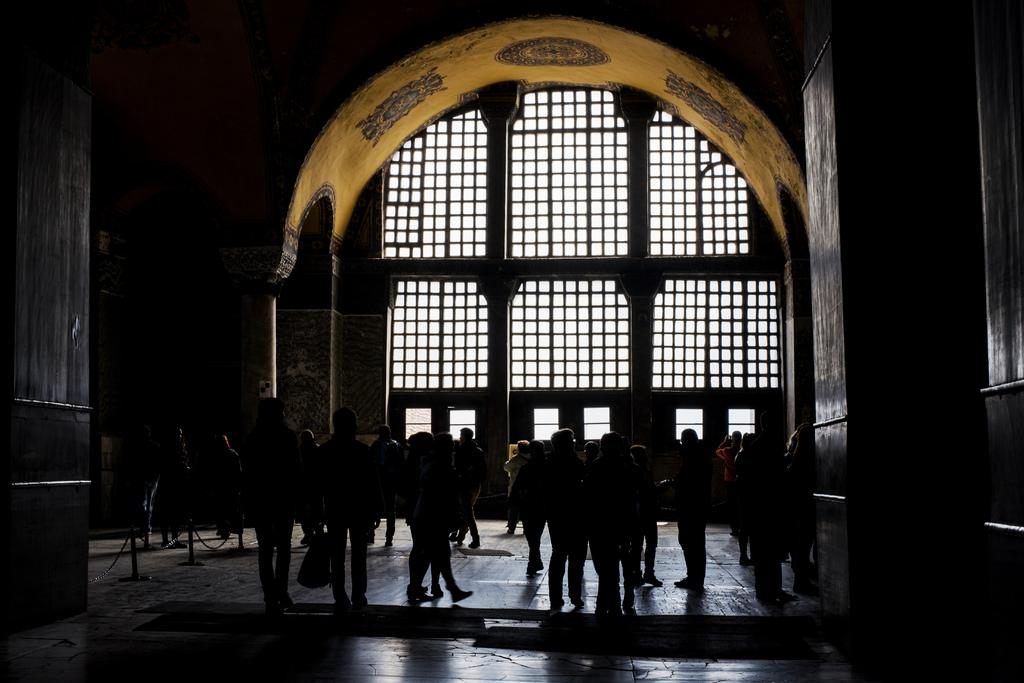How many people are in the group that is visible in the image? There is a group of people standing in the image, but the exact number is not specified. What can be seen in the background of the image? There is an arch in the background of the image. What type of structure is visible in the image? There is railing visible in the image. What is the color of the sky in the image? The sky appears to be white in color. What time is displayed on the clock in the image? There is no clock present in the image. What type of teeth can be seen in the image? There are no teeth visible in the image. 